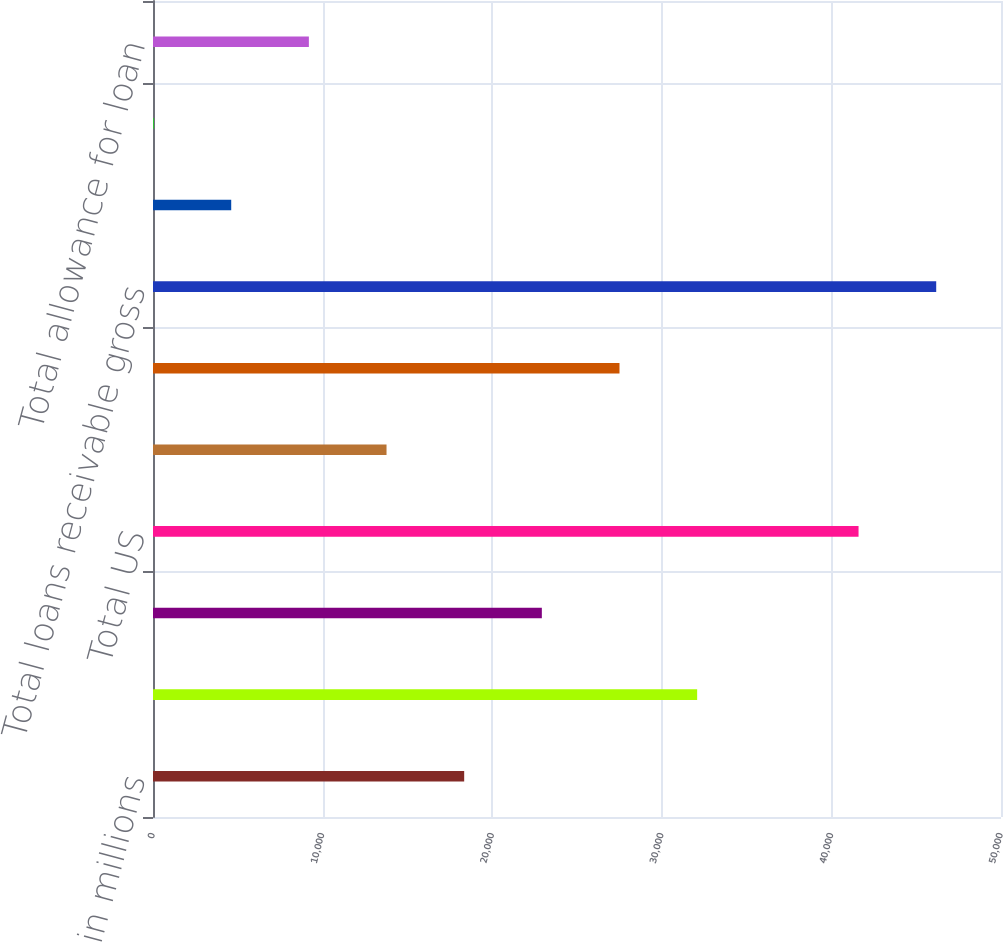<chart> <loc_0><loc_0><loc_500><loc_500><bar_chart><fcel>in millions<fcel>Loans to PWM clients<fcel>Commercial real estate<fcel>Total US<fcel>Corporate loans<fcel>Total non-US<fcel>Total loans receivable gross<fcel>US<fcel>Non-US<fcel>Total allowance for loan<nl><fcel>18348.2<fcel>32084.6<fcel>22927<fcel>41601<fcel>13769.4<fcel>27505.8<fcel>46179.8<fcel>4611.8<fcel>33<fcel>9190.6<nl></chart> 